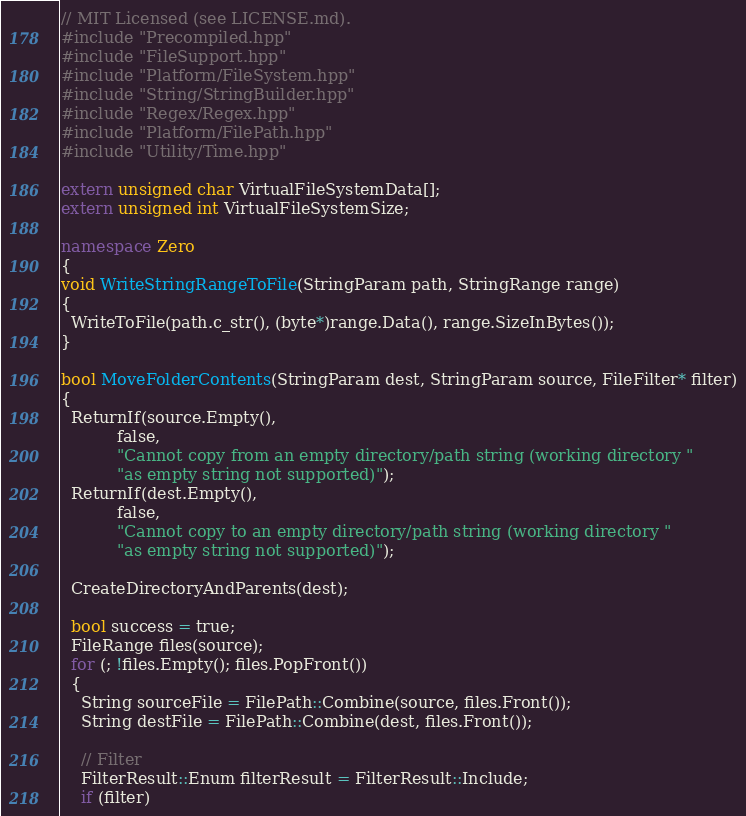Convert code to text. <code><loc_0><loc_0><loc_500><loc_500><_C++_>// MIT Licensed (see LICENSE.md).
#include "Precompiled.hpp"
#include "FileSupport.hpp"
#include "Platform/FileSystem.hpp"
#include "String/StringBuilder.hpp"
#include "Regex/Regex.hpp"
#include "Platform/FilePath.hpp"
#include "Utility/Time.hpp"

extern unsigned char VirtualFileSystemData[];
extern unsigned int VirtualFileSystemSize;

namespace Zero
{
void WriteStringRangeToFile(StringParam path, StringRange range)
{
  WriteToFile(path.c_str(), (byte*)range.Data(), range.SizeInBytes());
}

bool MoveFolderContents(StringParam dest, StringParam source, FileFilter* filter)
{
  ReturnIf(source.Empty(),
           false,
           "Cannot copy from an empty directory/path string (working directory "
           "as empty string not supported)");
  ReturnIf(dest.Empty(),
           false,
           "Cannot copy to an empty directory/path string (working directory "
           "as empty string not supported)");

  CreateDirectoryAndParents(dest);

  bool success = true;
  FileRange files(source);
  for (; !files.Empty(); files.PopFront())
  {
    String sourceFile = FilePath::Combine(source, files.Front());
    String destFile = FilePath::Combine(dest, files.Front());

    // Filter
    FilterResult::Enum filterResult = FilterResult::Include;
    if (filter)</code> 